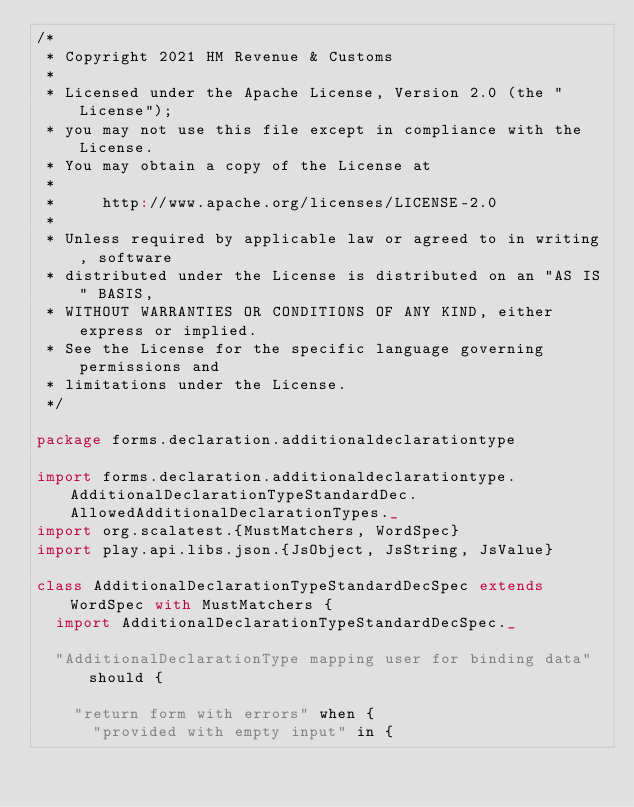<code> <loc_0><loc_0><loc_500><loc_500><_Scala_>/*
 * Copyright 2021 HM Revenue & Customs
 *
 * Licensed under the Apache License, Version 2.0 (the "License");
 * you may not use this file except in compliance with the License.
 * You may obtain a copy of the License at
 *
 *     http://www.apache.org/licenses/LICENSE-2.0
 *
 * Unless required by applicable law or agreed to in writing, software
 * distributed under the License is distributed on an "AS IS" BASIS,
 * WITHOUT WARRANTIES OR CONDITIONS OF ANY KIND, either express or implied.
 * See the License for the specific language governing permissions and
 * limitations under the License.
 */

package forms.declaration.additionaldeclarationtype

import forms.declaration.additionaldeclarationtype.AdditionalDeclarationTypeStandardDec.AllowedAdditionalDeclarationTypes._
import org.scalatest.{MustMatchers, WordSpec}
import play.api.libs.json.{JsObject, JsString, JsValue}

class AdditionalDeclarationTypeStandardDecSpec extends WordSpec with MustMatchers {
  import AdditionalDeclarationTypeStandardDecSpec._

  "AdditionalDeclarationType mapping user for binding data" should {

    "return form with errors" when {
      "provided with empty input" in {</code> 